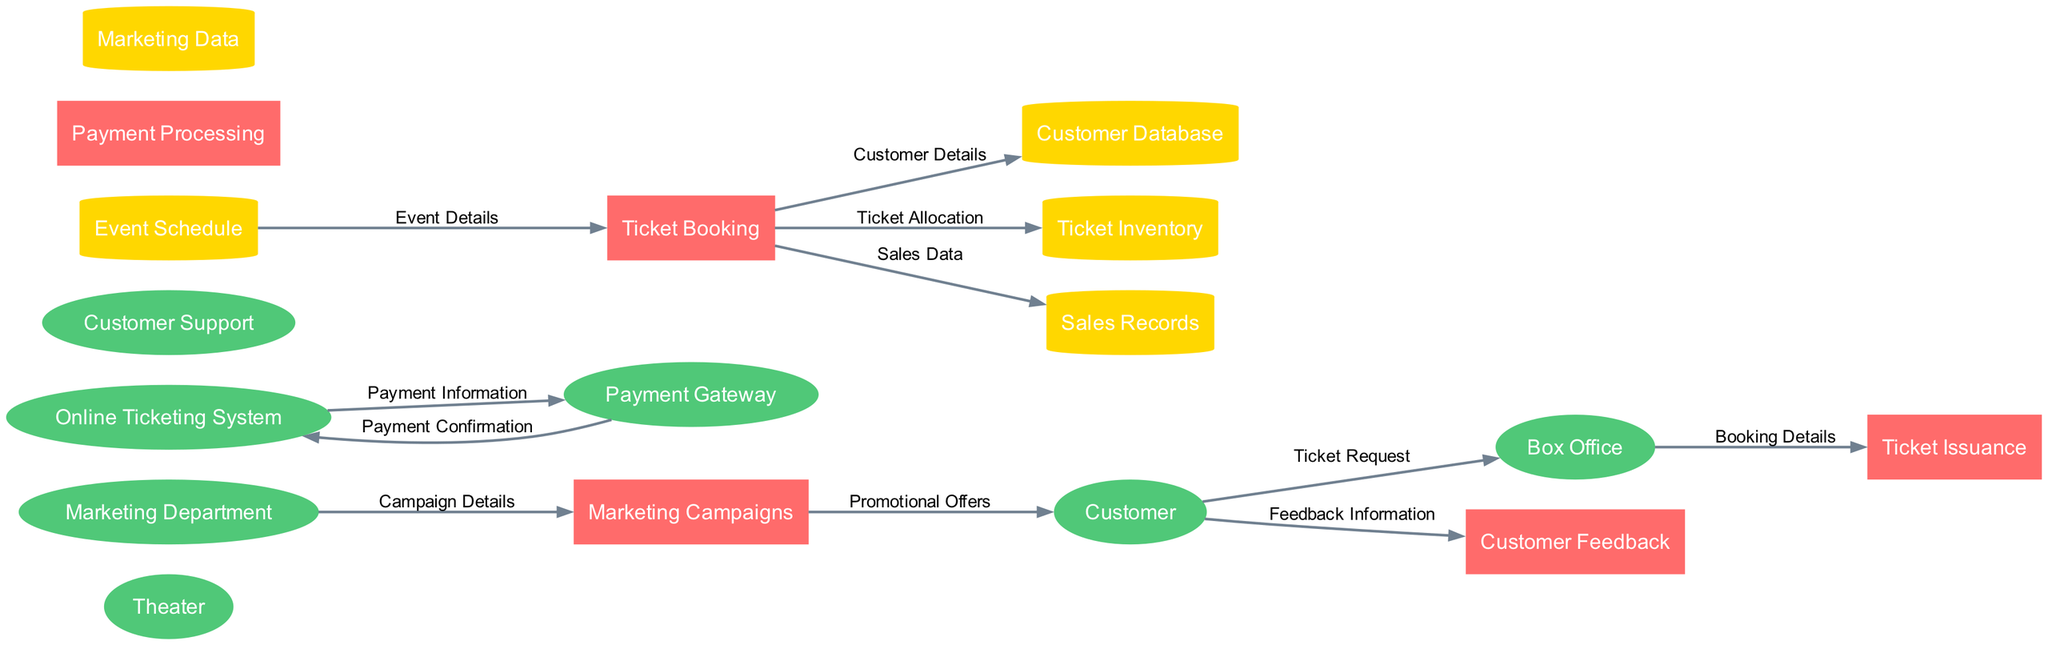What are the entities present in the diagram? The entities present in the diagram are the Theater, Box Office, Customer, Online Ticketing System, Payment Gateway, Customer Support, and Marketing Department. They represent the main actors involved in the ticket sales and distribution process
Answer: Theater, Box Office, Customer, Online Ticketing System, Payment Gateway, Customer Support, Marketing Department How many processes are depicted in the diagram? The diagram contains five processes, which are Ticket Booking, Payment Processing, Ticket Issuance, Marketing Campaigns, and Customer Feedback. These processes outline the various actions taken during ticket sales and management
Answer: Five Which entity directly provides feedback information? The Customer is the entity that directly provides feedback information, indicating that the customers are the source of feedback to the Customer Feedback process
Answer: Customer What is the source of the promotional offers? The source of the promotional offers is the Marketing Campaigns process, which receives its details from the Marketing Department and aims to reach out to customers with these offers
Answer: Marketing Campaigns How many data stores are involved in this process? There are four data stores involved in this process: Customer Database, Ticket Inventory, Sales Records, and Event Schedule. These stores maintain the necessary data for effective management of ticket sales and distribution
Answer: Four What data flows from the Event Schedule to the Ticket Booking process? The data that flows from the Event Schedule to the Ticket Booking process is the Event Details, which are necessary for customers to book tickets for specific events
Answer: Event Details What happens to the booking details after they reach the Box Office? After the booking details reach the Box Office, they are sent to the Ticket Issuance process, where tickets are issued based on the received details
Answer: Ticket Issuance Which process receives campaign details from the Marketing Department? The Marketing Campaigns process receives campaign details from the Marketing Department, indicating the flow of information necessary for creating promotional strategies
Answer: Marketing Campaigns What is required to complete the ticket booking? Completing the ticket booking requires Customer Details, which are entered into the Customer Database during the Ticket Booking process
Answer: Customer Details 